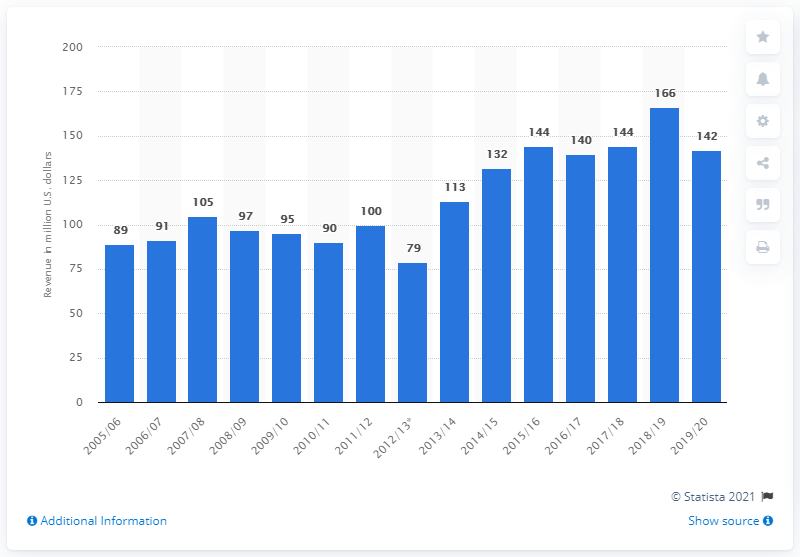Outline some significant characteristics in this image. The Dallas Stars earned $142 million in the 2019/2020 season. 